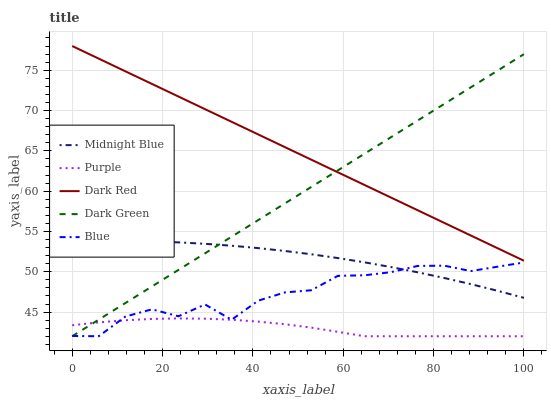Does Purple have the minimum area under the curve?
Answer yes or no. Yes. Does Dark Red have the maximum area under the curve?
Answer yes or no. Yes. Does Midnight Blue have the minimum area under the curve?
Answer yes or no. No. Does Midnight Blue have the maximum area under the curve?
Answer yes or no. No. Is Dark Red the smoothest?
Answer yes or no. Yes. Is Blue the roughest?
Answer yes or no. Yes. Is Midnight Blue the smoothest?
Answer yes or no. No. Is Midnight Blue the roughest?
Answer yes or no. No. Does Purple have the lowest value?
Answer yes or no. Yes. Does Midnight Blue have the lowest value?
Answer yes or no. No. Does Dark Red have the highest value?
Answer yes or no. Yes. Does Midnight Blue have the highest value?
Answer yes or no. No. Is Purple less than Midnight Blue?
Answer yes or no. Yes. Is Dark Red greater than Midnight Blue?
Answer yes or no. Yes. Does Purple intersect Dark Green?
Answer yes or no. Yes. Is Purple less than Dark Green?
Answer yes or no. No. Is Purple greater than Dark Green?
Answer yes or no. No. Does Purple intersect Midnight Blue?
Answer yes or no. No. 